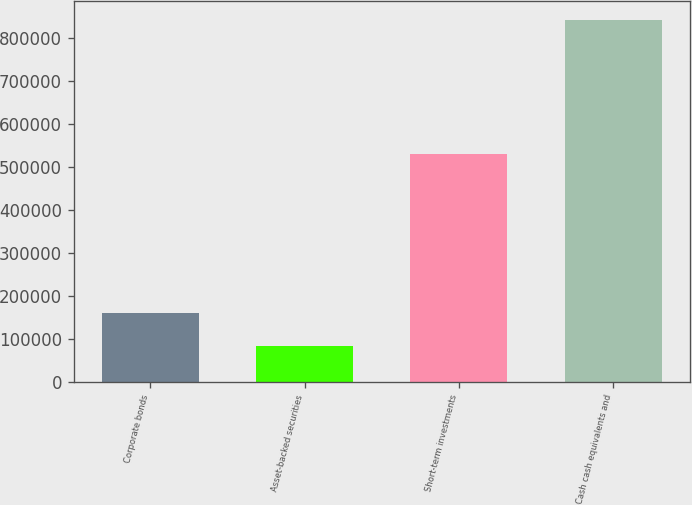<chart> <loc_0><loc_0><loc_500><loc_500><bar_chart><fcel>Corporate bonds<fcel>Asset-backed securities<fcel>Short-term investments<fcel>Cash cash equivalents and<nl><fcel>160907<fcel>83517<fcel>530467<fcel>844084<nl></chart> 